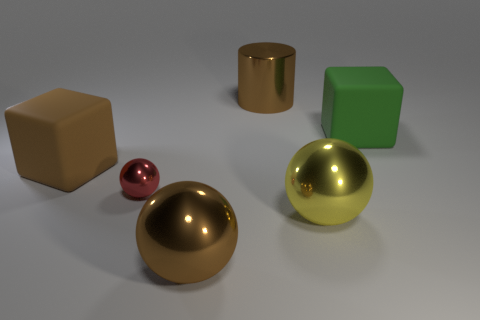Add 2 cyan cubes. How many objects exist? 8 Subtract all cylinders. How many objects are left? 5 Add 4 objects. How many objects are left? 10 Add 3 big brown objects. How many big brown objects exist? 6 Subtract 0 yellow cylinders. How many objects are left? 6 Subtract all tiny cyan metal balls. Subtract all big yellow things. How many objects are left? 5 